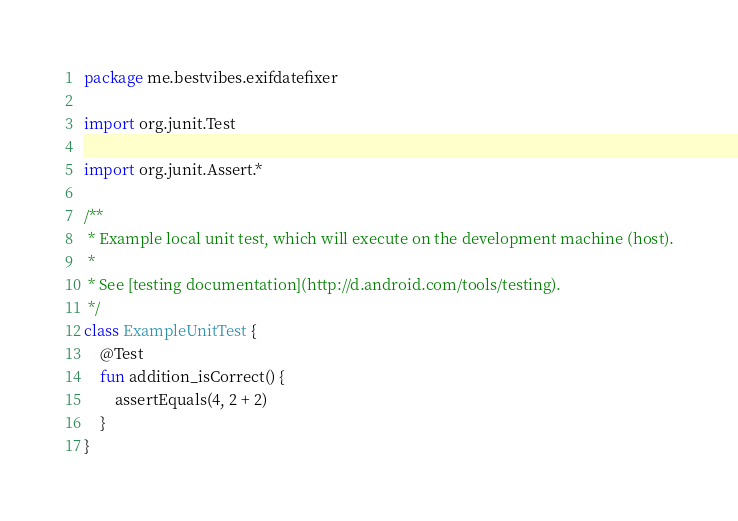<code> <loc_0><loc_0><loc_500><loc_500><_Kotlin_>package me.bestvibes.exifdatefixer

import org.junit.Test

import org.junit.Assert.*

/**
 * Example local unit test, which will execute on the development machine (host).
 *
 * See [testing documentation](http://d.android.com/tools/testing).
 */
class ExampleUnitTest {
    @Test
    fun addition_isCorrect() {
        assertEquals(4, 2 + 2)
    }
}
</code> 